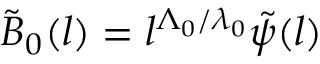<formula> <loc_0><loc_0><loc_500><loc_500>\tilde { B } _ { 0 } ( l ) = l ^ { \Lambda _ { 0 } / \lambda _ { 0 } } \tilde { \psi } ( l )</formula> 